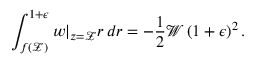<formula> <loc_0><loc_0><loc_500><loc_500>\int _ { f ( \mathcal { Z } ) } ^ { 1 + \epsilon } w | _ { z = \mathcal { Z } } r \, d r = - \frac { 1 } { 2 } \mathcal { W } \left ( 1 + \epsilon \right ) ^ { 2 } .</formula> 